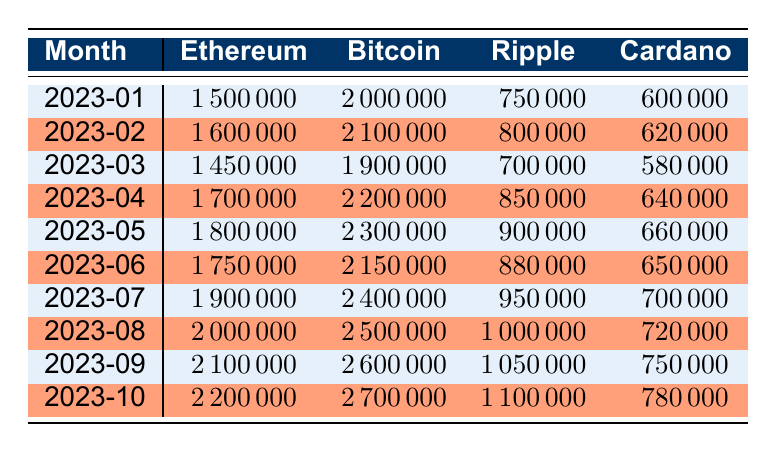What was the transaction volume for Bitcoin in March 2023? In the row for March 2023, the transaction volume for Bitcoin is listed directly in the table. Referring to this row, the value is clearly indicated.
Answer: 1900000 Which blockchain had the highest transaction volume in August 2023? Looking at the row for August 2023, the transaction volumes are as follows: Ethereum: 2000000, Bitcoin: 2500000, Ripple: 1000000, Cardano: 720000. The highest value among these is for Bitcoin.
Answer: Bitcoin What is the total transaction volume for Ethereum from January to June 2023? To calculate the total volume for Ethereum, we add the monthly volumes from January (1500000), February (1600000), March (1450000), April (1700000), May (1800000), and June (1750000). The total sum is 1500000 + 1600000 + 1450000 + 1700000 + 1800000 + 1750000 = 10800000.
Answer: 10800000 Was the transaction volume for Cardano higher in April or May 2023? In the table, the transaction volumes for Cardano are listed as 640000 for April and 660000 for May. Comparing these two values, 660000 (May) is greater than 640000 (April). Therefore, May had a higher transaction volume.
Answer: Yes What was the percentage increase in transaction volume for Ripple from January to October 2023? First, we find the Ripple transaction volumes for January (750000) and October (1100000). The increase is calculated as (1100000 - 750000) = 350000. To find the percentage increase, we divide the increase by the original value (750000) and multiply by 100: (350000 / 750000) * 100 = 46.67%. Thus, the percentage increase is approximately 46.67%.
Answer: 46.67% In which month did Ethereum reach its highest transaction volume? By examining the monthly volumes for Ethereum in the table, the values are: January: 1500000, February: 1600000, March: 1450000, April: 1700000, May: 1800000, June: 1750000, July: 1900000, August: 2000000, September: 2100000, October: 2200000. The highest value is in October with 2200000.
Answer: October What was the average transaction volume for Bitcoin from January to September 2023? We sum the transaction volumes for Bitcoin from January (2000000), February (2100000), March (1900000), April (2200000), May (2300000), June (2150000), July (2400000), August (2500000), and September (2600000). The total sum is 2000000 + 2100000 + 1900000 + 2200000 + 2300000 + 2150000 + 2400000 + 2500000 + 2600000 = 18500000. There are 9 months, so the average is 18500000 / 9 = 2055555.56 or approximately 2055556.
Answer: 2055556 Did Ripple consistently have a transaction volume above 800000 from January to October 2023? Analyzing the Ripple transaction volumes: January (750000), February (800000), March (700000), April (850000), May (900000), June (880000), July (950000), August (1000000), September (1050000), October (1100000), we see that January and March are below 800000. Thus, it was not consistent.
Answer: No 